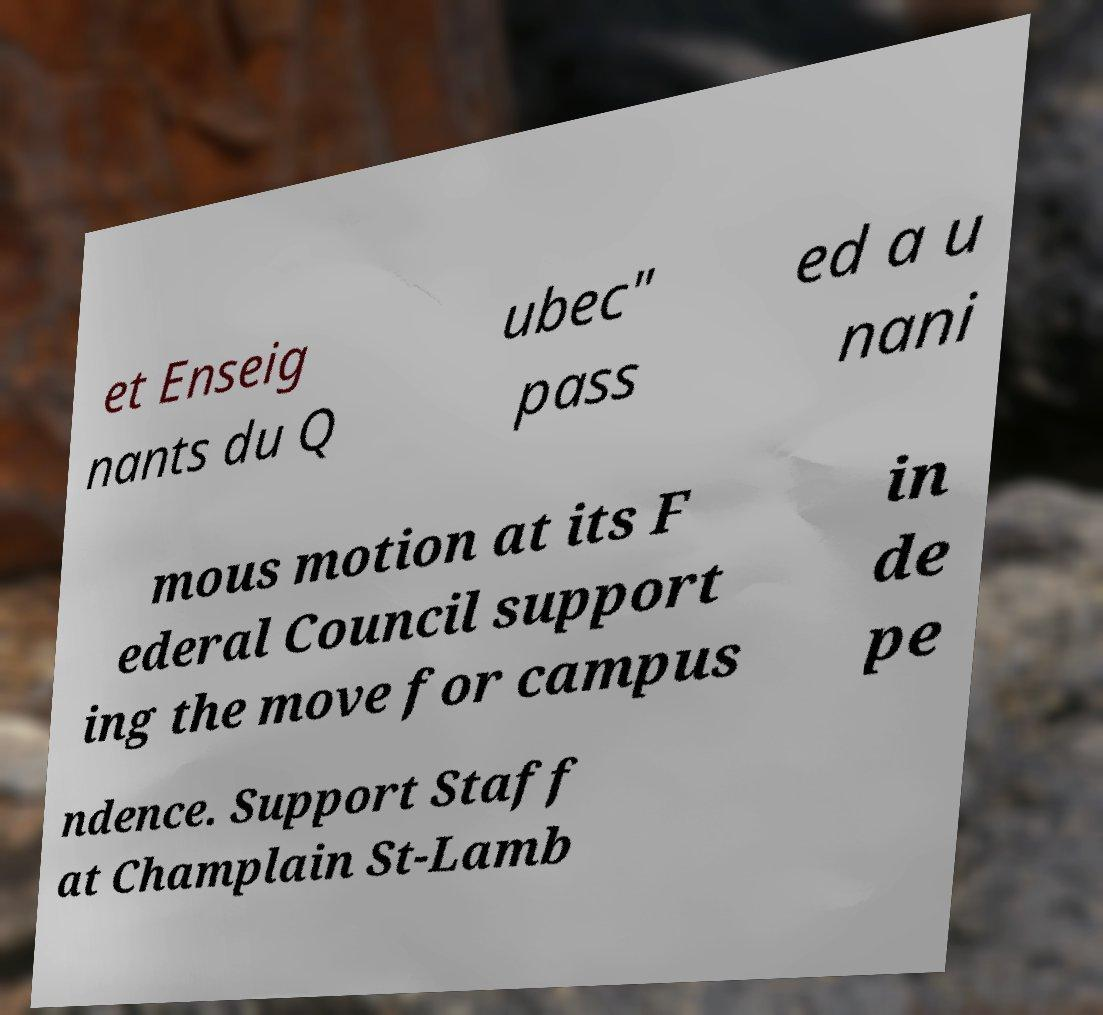For documentation purposes, I need the text within this image transcribed. Could you provide that? et Enseig nants du Q ubec" pass ed a u nani mous motion at its F ederal Council support ing the move for campus in de pe ndence. Support Staff at Champlain St-Lamb 